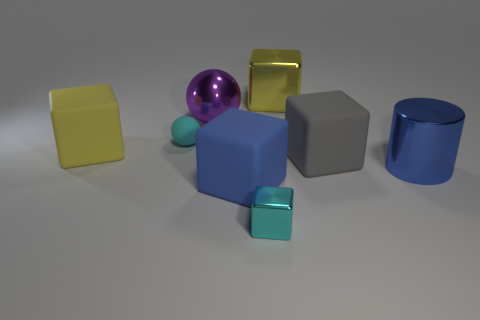Subtract 1 cubes. How many cubes are left? 4 Subtract all big shiny cubes. How many cubes are left? 4 Subtract all gray cubes. How many cubes are left? 4 Subtract all red cubes. Subtract all brown cylinders. How many cubes are left? 5 Add 1 blue shiny cylinders. How many objects exist? 9 Subtract all cubes. How many objects are left? 3 Add 7 big gray rubber blocks. How many big gray rubber blocks exist? 8 Subtract 0 blue balls. How many objects are left? 8 Subtract all green metallic blocks. Subtract all large yellow metallic objects. How many objects are left? 7 Add 8 gray matte cubes. How many gray matte cubes are left? 9 